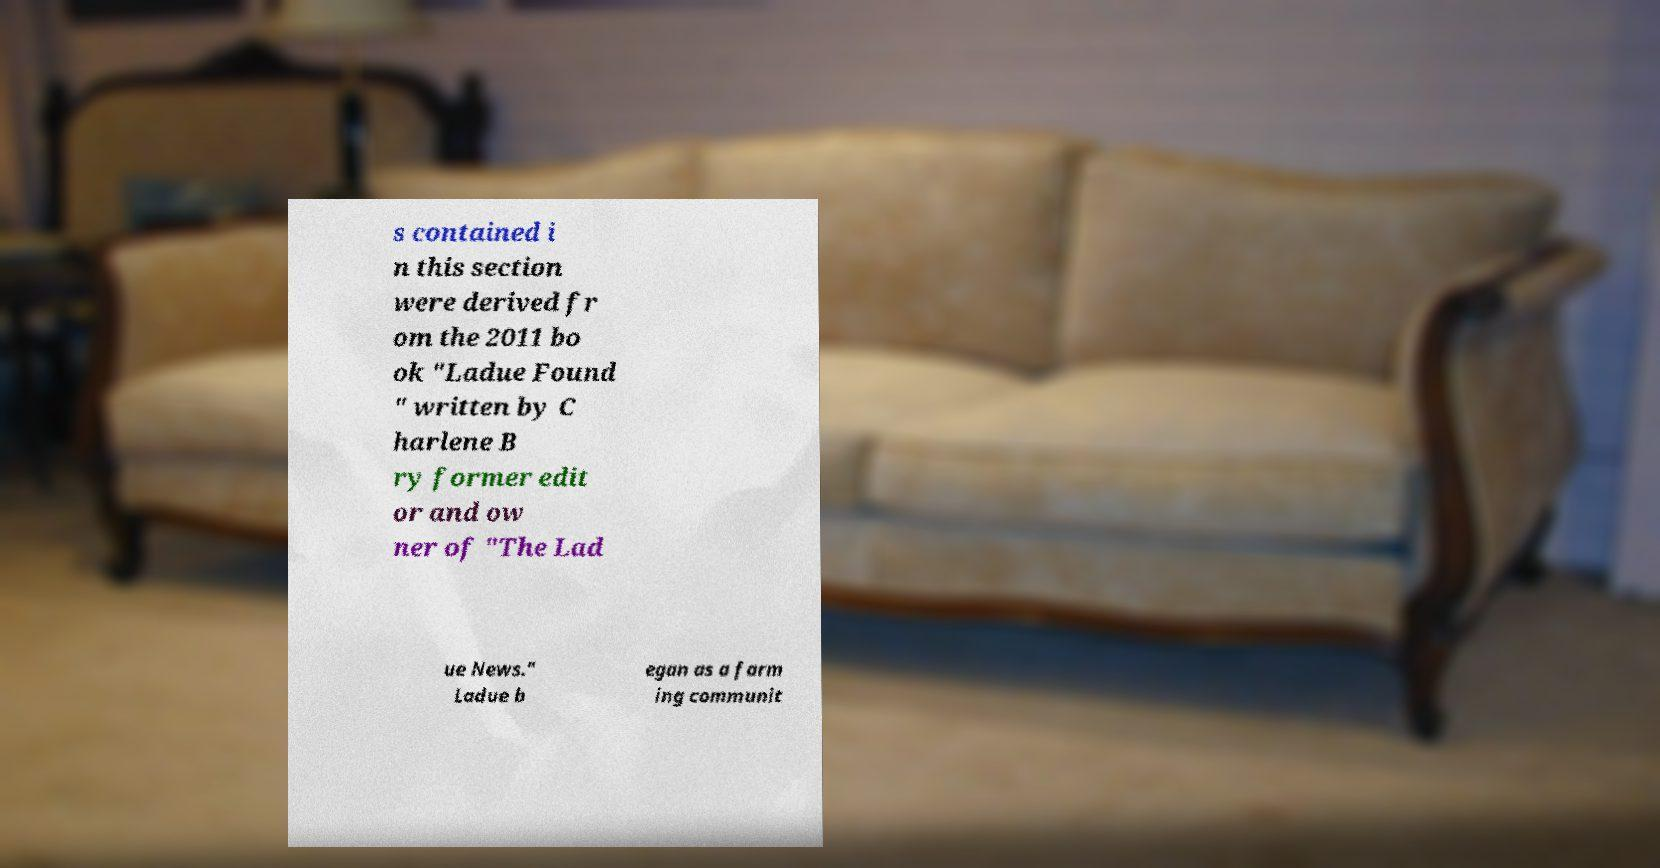Can you accurately transcribe the text from the provided image for me? s contained i n this section were derived fr om the 2011 bo ok "Ladue Found " written by C harlene B ry former edit or and ow ner of "The Lad ue News." Ladue b egan as a farm ing communit 